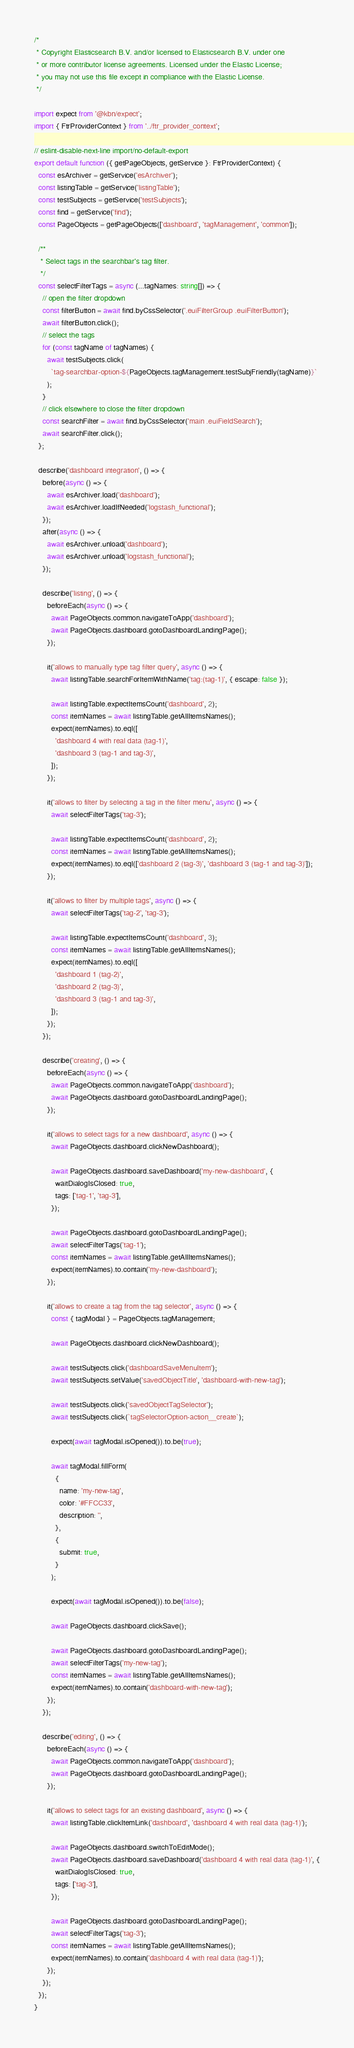<code> <loc_0><loc_0><loc_500><loc_500><_TypeScript_>/*
 * Copyright Elasticsearch B.V. and/or licensed to Elasticsearch B.V. under one
 * or more contributor license agreements. Licensed under the Elastic License;
 * you may not use this file except in compliance with the Elastic License.
 */

import expect from '@kbn/expect';
import { FtrProviderContext } from '../ftr_provider_context';

// eslint-disable-next-line import/no-default-export
export default function ({ getPageObjects, getService }: FtrProviderContext) {
  const esArchiver = getService('esArchiver');
  const listingTable = getService('listingTable');
  const testSubjects = getService('testSubjects');
  const find = getService('find');
  const PageObjects = getPageObjects(['dashboard', 'tagManagement', 'common']);

  /**
   * Select tags in the searchbar's tag filter.
   */
  const selectFilterTags = async (...tagNames: string[]) => {
    // open the filter dropdown
    const filterButton = await find.byCssSelector('.euiFilterGroup .euiFilterButton');
    await filterButton.click();
    // select the tags
    for (const tagName of tagNames) {
      await testSubjects.click(
        `tag-searchbar-option-${PageObjects.tagManagement.testSubjFriendly(tagName)}`
      );
    }
    // click elsewhere to close the filter dropdown
    const searchFilter = await find.byCssSelector('main .euiFieldSearch');
    await searchFilter.click();
  };

  describe('dashboard integration', () => {
    before(async () => {
      await esArchiver.load('dashboard');
      await esArchiver.loadIfNeeded('logstash_functional');
    });
    after(async () => {
      await esArchiver.unload('dashboard');
      await esArchiver.unload('logstash_functional');
    });

    describe('listing', () => {
      beforeEach(async () => {
        await PageObjects.common.navigateToApp('dashboard');
        await PageObjects.dashboard.gotoDashboardLandingPage();
      });

      it('allows to manually type tag filter query', async () => {
        await listingTable.searchForItemWithName('tag:(tag-1)', { escape: false });

        await listingTable.expectItemsCount('dashboard', 2);
        const itemNames = await listingTable.getAllItemsNames();
        expect(itemNames).to.eql([
          'dashboard 4 with real data (tag-1)',
          'dashboard 3 (tag-1 and tag-3)',
        ]);
      });

      it('allows to filter by selecting a tag in the filter menu', async () => {
        await selectFilterTags('tag-3');

        await listingTable.expectItemsCount('dashboard', 2);
        const itemNames = await listingTable.getAllItemsNames();
        expect(itemNames).to.eql(['dashboard 2 (tag-3)', 'dashboard 3 (tag-1 and tag-3)']);
      });

      it('allows to filter by multiple tags', async () => {
        await selectFilterTags('tag-2', 'tag-3');

        await listingTable.expectItemsCount('dashboard', 3);
        const itemNames = await listingTable.getAllItemsNames();
        expect(itemNames).to.eql([
          'dashboard 1 (tag-2)',
          'dashboard 2 (tag-3)',
          'dashboard 3 (tag-1 and tag-3)',
        ]);
      });
    });

    describe('creating', () => {
      beforeEach(async () => {
        await PageObjects.common.navigateToApp('dashboard');
        await PageObjects.dashboard.gotoDashboardLandingPage();
      });

      it('allows to select tags for a new dashboard', async () => {
        await PageObjects.dashboard.clickNewDashboard();

        await PageObjects.dashboard.saveDashboard('my-new-dashboard', {
          waitDialogIsClosed: true,
          tags: ['tag-1', 'tag-3'],
        });

        await PageObjects.dashboard.gotoDashboardLandingPage();
        await selectFilterTags('tag-1');
        const itemNames = await listingTable.getAllItemsNames();
        expect(itemNames).to.contain('my-new-dashboard');
      });

      it('allows to create a tag from the tag selector', async () => {
        const { tagModal } = PageObjects.tagManagement;

        await PageObjects.dashboard.clickNewDashboard();

        await testSubjects.click('dashboardSaveMenuItem');
        await testSubjects.setValue('savedObjectTitle', 'dashboard-with-new-tag');

        await testSubjects.click('savedObjectTagSelector');
        await testSubjects.click(`tagSelectorOption-action__create`);

        expect(await tagModal.isOpened()).to.be(true);

        await tagModal.fillForm(
          {
            name: 'my-new-tag',
            color: '#FFCC33',
            description: '',
          },
          {
            submit: true,
          }
        );

        expect(await tagModal.isOpened()).to.be(false);

        await PageObjects.dashboard.clickSave();

        await PageObjects.dashboard.gotoDashboardLandingPage();
        await selectFilterTags('my-new-tag');
        const itemNames = await listingTable.getAllItemsNames();
        expect(itemNames).to.contain('dashboard-with-new-tag');
      });
    });

    describe('editing', () => {
      beforeEach(async () => {
        await PageObjects.common.navigateToApp('dashboard');
        await PageObjects.dashboard.gotoDashboardLandingPage();
      });

      it('allows to select tags for an existing dashboard', async () => {
        await listingTable.clickItemLink('dashboard', 'dashboard 4 with real data (tag-1)');

        await PageObjects.dashboard.switchToEditMode();
        await PageObjects.dashboard.saveDashboard('dashboard 4 with real data (tag-1)', {
          waitDialogIsClosed: true,
          tags: ['tag-3'],
        });

        await PageObjects.dashboard.gotoDashboardLandingPage();
        await selectFilterTags('tag-3');
        const itemNames = await listingTable.getAllItemsNames();
        expect(itemNames).to.contain('dashboard 4 with real data (tag-1)');
      });
    });
  });
}
</code> 